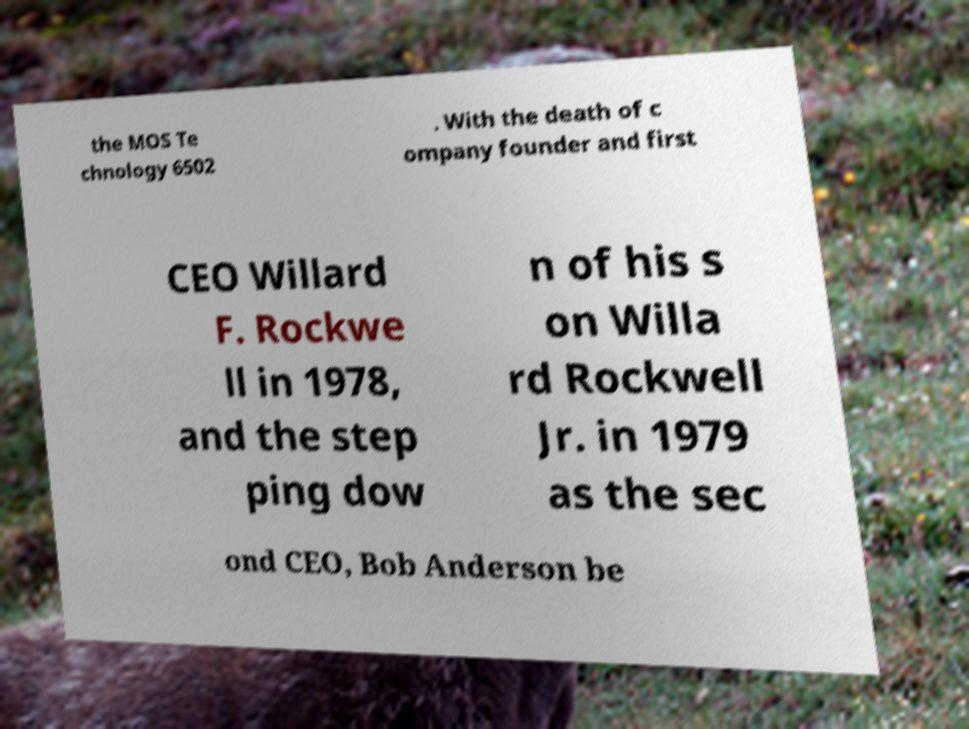Please read and relay the text visible in this image. What does it say? the MOS Te chnology 6502 . With the death of c ompany founder and first CEO Willard F. Rockwe ll in 1978, and the step ping dow n of his s on Willa rd Rockwell Jr. in 1979 as the sec ond CEO, Bob Anderson be 